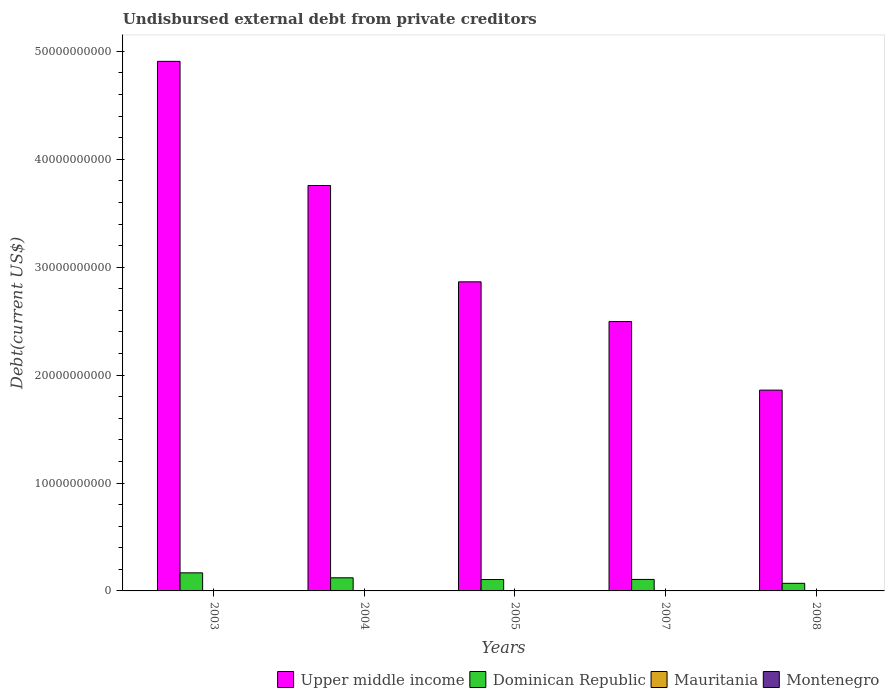Are the number of bars on each tick of the X-axis equal?
Provide a succinct answer. Yes. How many bars are there on the 4th tick from the right?
Ensure brevity in your answer.  4. What is the label of the 3rd group of bars from the left?
Your answer should be compact. 2005. What is the total debt in Mauritania in 2007?
Make the answer very short. 5.10e+04. Across all years, what is the maximum total debt in Mauritania?
Keep it short and to the point. 1.71e+07. Across all years, what is the minimum total debt in Dominican Republic?
Provide a short and direct response. 7.04e+08. In which year was the total debt in Upper middle income maximum?
Provide a short and direct response. 2003. In which year was the total debt in Upper middle income minimum?
Provide a short and direct response. 2008. What is the total total debt in Montenegro in the graph?
Offer a very short reply. 6.93e+07. What is the difference between the total debt in Dominican Republic in 2004 and that in 2008?
Provide a succinct answer. 5.11e+08. What is the difference between the total debt in Upper middle income in 2005 and the total debt in Mauritania in 2003?
Your answer should be very brief. 2.86e+1. What is the average total debt in Upper middle income per year?
Give a very brief answer. 3.18e+1. In the year 2005, what is the difference between the total debt in Upper middle income and total debt in Mauritania?
Your answer should be compact. 2.86e+1. What is the difference between the highest and the second highest total debt in Upper middle income?
Ensure brevity in your answer.  1.15e+1. What is the difference between the highest and the lowest total debt in Dominican Republic?
Offer a terse response. 9.72e+08. In how many years, is the total debt in Upper middle income greater than the average total debt in Upper middle income taken over all years?
Offer a very short reply. 2. Is the sum of the total debt in Dominican Republic in 2004 and 2007 greater than the maximum total debt in Montenegro across all years?
Provide a succinct answer. Yes. What does the 1st bar from the left in 2008 represents?
Keep it short and to the point. Upper middle income. What does the 4th bar from the right in 2003 represents?
Provide a short and direct response. Upper middle income. Is it the case that in every year, the sum of the total debt in Montenegro and total debt in Upper middle income is greater than the total debt in Dominican Republic?
Make the answer very short. Yes. How many bars are there?
Your answer should be compact. 20. What is the difference between two consecutive major ticks on the Y-axis?
Your response must be concise. 1.00e+1. Does the graph contain any zero values?
Make the answer very short. No. Does the graph contain grids?
Keep it short and to the point. No. How many legend labels are there?
Offer a terse response. 4. What is the title of the graph?
Your answer should be very brief. Undisbursed external debt from private creditors. What is the label or title of the Y-axis?
Make the answer very short. Debt(current US$). What is the Debt(current US$) of Upper middle income in 2003?
Your response must be concise. 4.91e+1. What is the Debt(current US$) in Dominican Republic in 2003?
Make the answer very short. 1.68e+09. What is the Debt(current US$) of Mauritania in 2003?
Ensure brevity in your answer.  1.71e+07. What is the Debt(current US$) of Montenegro in 2003?
Make the answer very short. 2.10e+06. What is the Debt(current US$) of Upper middle income in 2004?
Provide a short and direct response. 3.76e+1. What is the Debt(current US$) in Dominican Republic in 2004?
Offer a very short reply. 1.22e+09. What is the Debt(current US$) in Mauritania in 2004?
Offer a terse response. 1.51e+07. What is the Debt(current US$) of Montenegro in 2004?
Give a very brief answer. 2.10e+06. What is the Debt(current US$) in Upper middle income in 2005?
Make the answer very short. 2.86e+1. What is the Debt(current US$) of Dominican Republic in 2005?
Your response must be concise. 1.06e+09. What is the Debt(current US$) in Mauritania in 2005?
Make the answer very short. 5.10e+04. What is the Debt(current US$) of Montenegro in 2005?
Keep it short and to the point. 2.10e+06. What is the Debt(current US$) in Upper middle income in 2007?
Offer a terse response. 2.50e+1. What is the Debt(current US$) in Dominican Republic in 2007?
Keep it short and to the point. 1.07e+09. What is the Debt(current US$) in Mauritania in 2007?
Provide a short and direct response. 5.10e+04. What is the Debt(current US$) in Montenegro in 2007?
Provide a succinct answer. 3.24e+07. What is the Debt(current US$) in Upper middle income in 2008?
Ensure brevity in your answer.  1.86e+1. What is the Debt(current US$) in Dominican Republic in 2008?
Offer a terse response. 7.04e+08. What is the Debt(current US$) of Mauritania in 2008?
Offer a terse response. 3.00e+04. What is the Debt(current US$) in Montenegro in 2008?
Keep it short and to the point. 3.06e+07. Across all years, what is the maximum Debt(current US$) in Upper middle income?
Offer a terse response. 4.91e+1. Across all years, what is the maximum Debt(current US$) of Dominican Republic?
Provide a short and direct response. 1.68e+09. Across all years, what is the maximum Debt(current US$) of Mauritania?
Provide a short and direct response. 1.71e+07. Across all years, what is the maximum Debt(current US$) in Montenegro?
Your answer should be compact. 3.24e+07. Across all years, what is the minimum Debt(current US$) in Upper middle income?
Give a very brief answer. 1.86e+1. Across all years, what is the minimum Debt(current US$) in Dominican Republic?
Offer a terse response. 7.04e+08. Across all years, what is the minimum Debt(current US$) in Mauritania?
Provide a short and direct response. 3.00e+04. Across all years, what is the minimum Debt(current US$) of Montenegro?
Your answer should be compact. 2.10e+06. What is the total Debt(current US$) in Upper middle income in the graph?
Provide a succinct answer. 1.59e+11. What is the total Debt(current US$) in Dominican Republic in the graph?
Ensure brevity in your answer.  5.72e+09. What is the total Debt(current US$) in Mauritania in the graph?
Keep it short and to the point. 3.23e+07. What is the total Debt(current US$) of Montenegro in the graph?
Offer a terse response. 6.93e+07. What is the difference between the Debt(current US$) of Upper middle income in 2003 and that in 2004?
Your answer should be compact. 1.15e+1. What is the difference between the Debt(current US$) in Dominican Republic in 2003 and that in 2004?
Your answer should be compact. 4.60e+08. What is the difference between the Debt(current US$) in Mauritania in 2003 and that in 2004?
Provide a succinct answer. 2.07e+06. What is the difference between the Debt(current US$) of Montenegro in 2003 and that in 2004?
Make the answer very short. 0. What is the difference between the Debt(current US$) of Upper middle income in 2003 and that in 2005?
Your answer should be very brief. 2.04e+1. What is the difference between the Debt(current US$) of Dominican Republic in 2003 and that in 2005?
Your answer should be compact. 6.19e+08. What is the difference between the Debt(current US$) in Mauritania in 2003 and that in 2005?
Offer a terse response. 1.71e+07. What is the difference between the Debt(current US$) in Upper middle income in 2003 and that in 2007?
Your response must be concise. 2.41e+1. What is the difference between the Debt(current US$) of Dominican Republic in 2003 and that in 2007?
Offer a very short reply. 6.10e+08. What is the difference between the Debt(current US$) in Mauritania in 2003 and that in 2007?
Provide a short and direct response. 1.71e+07. What is the difference between the Debt(current US$) of Montenegro in 2003 and that in 2007?
Ensure brevity in your answer.  -3.03e+07. What is the difference between the Debt(current US$) in Upper middle income in 2003 and that in 2008?
Your response must be concise. 3.05e+1. What is the difference between the Debt(current US$) in Dominican Republic in 2003 and that in 2008?
Provide a succinct answer. 9.72e+08. What is the difference between the Debt(current US$) in Mauritania in 2003 and that in 2008?
Your answer should be very brief. 1.71e+07. What is the difference between the Debt(current US$) of Montenegro in 2003 and that in 2008?
Give a very brief answer. -2.85e+07. What is the difference between the Debt(current US$) of Upper middle income in 2004 and that in 2005?
Provide a succinct answer. 8.93e+09. What is the difference between the Debt(current US$) in Dominican Republic in 2004 and that in 2005?
Your answer should be compact. 1.59e+08. What is the difference between the Debt(current US$) in Mauritania in 2004 and that in 2005?
Provide a short and direct response. 1.50e+07. What is the difference between the Debt(current US$) of Montenegro in 2004 and that in 2005?
Your answer should be compact. 0. What is the difference between the Debt(current US$) in Upper middle income in 2004 and that in 2007?
Your answer should be compact. 1.26e+1. What is the difference between the Debt(current US$) in Dominican Republic in 2004 and that in 2007?
Your answer should be very brief. 1.50e+08. What is the difference between the Debt(current US$) in Mauritania in 2004 and that in 2007?
Make the answer very short. 1.50e+07. What is the difference between the Debt(current US$) of Montenegro in 2004 and that in 2007?
Provide a succinct answer. -3.03e+07. What is the difference between the Debt(current US$) in Upper middle income in 2004 and that in 2008?
Ensure brevity in your answer.  1.90e+1. What is the difference between the Debt(current US$) in Dominican Republic in 2004 and that in 2008?
Offer a terse response. 5.11e+08. What is the difference between the Debt(current US$) in Mauritania in 2004 and that in 2008?
Ensure brevity in your answer.  1.50e+07. What is the difference between the Debt(current US$) of Montenegro in 2004 and that in 2008?
Ensure brevity in your answer.  -2.85e+07. What is the difference between the Debt(current US$) of Upper middle income in 2005 and that in 2007?
Keep it short and to the point. 3.68e+09. What is the difference between the Debt(current US$) in Dominican Republic in 2005 and that in 2007?
Give a very brief answer. -8.96e+06. What is the difference between the Debt(current US$) of Montenegro in 2005 and that in 2007?
Your answer should be very brief. -3.03e+07. What is the difference between the Debt(current US$) in Upper middle income in 2005 and that in 2008?
Give a very brief answer. 1.00e+1. What is the difference between the Debt(current US$) in Dominican Republic in 2005 and that in 2008?
Your answer should be compact. 3.53e+08. What is the difference between the Debt(current US$) in Mauritania in 2005 and that in 2008?
Offer a very short reply. 2.10e+04. What is the difference between the Debt(current US$) of Montenegro in 2005 and that in 2008?
Give a very brief answer. -2.85e+07. What is the difference between the Debt(current US$) in Upper middle income in 2007 and that in 2008?
Your answer should be very brief. 6.36e+09. What is the difference between the Debt(current US$) of Dominican Republic in 2007 and that in 2008?
Your response must be concise. 3.62e+08. What is the difference between the Debt(current US$) of Mauritania in 2007 and that in 2008?
Offer a terse response. 2.10e+04. What is the difference between the Debt(current US$) of Montenegro in 2007 and that in 2008?
Your response must be concise. 1.77e+06. What is the difference between the Debt(current US$) in Upper middle income in 2003 and the Debt(current US$) in Dominican Republic in 2004?
Your answer should be compact. 4.79e+1. What is the difference between the Debt(current US$) of Upper middle income in 2003 and the Debt(current US$) of Mauritania in 2004?
Your answer should be compact. 4.91e+1. What is the difference between the Debt(current US$) of Upper middle income in 2003 and the Debt(current US$) of Montenegro in 2004?
Make the answer very short. 4.91e+1. What is the difference between the Debt(current US$) in Dominican Republic in 2003 and the Debt(current US$) in Mauritania in 2004?
Ensure brevity in your answer.  1.66e+09. What is the difference between the Debt(current US$) in Dominican Republic in 2003 and the Debt(current US$) in Montenegro in 2004?
Keep it short and to the point. 1.67e+09. What is the difference between the Debt(current US$) in Mauritania in 2003 and the Debt(current US$) in Montenegro in 2004?
Your answer should be compact. 1.50e+07. What is the difference between the Debt(current US$) of Upper middle income in 2003 and the Debt(current US$) of Dominican Republic in 2005?
Offer a terse response. 4.80e+1. What is the difference between the Debt(current US$) of Upper middle income in 2003 and the Debt(current US$) of Mauritania in 2005?
Your response must be concise. 4.91e+1. What is the difference between the Debt(current US$) in Upper middle income in 2003 and the Debt(current US$) in Montenegro in 2005?
Your answer should be compact. 4.91e+1. What is the difference between the Debt(current US$) of Dominican Republic in 2003 and the Debt(current US$) of Mauritania in 2005?
Ensure brevity in your answer.  1.68e+09. What is the difference between the Debt(current US$) in Dominican Republic in 2003 and the Debt(current US$) in Montenegro in 2005?
Ensure brevity in your answer.  1.67e+09. What is the difference between the Debt(current US$) in Mauritania in 2003 and the Debt(current US$) in Montenegro in 2005?
Keep it short and to the point. 1.50e+07. What is the difference between the Debt(current US$) in Upper middle income in 2003 and the Debt(current US$) in Dominican Republic in 2007?
Your response must be concise. 4.80e+1. What is the difference between the Debt(current US$) in Upper middle income in 2003 and the Debt(current US$) in Mauritania in 2007?
Offer a very short reply. 4.91e+1. What is the difference between the Debt(current US$) of Upper middle income in 2003 and the Debt(current US$) of Montenegro in 2007?
Provide a succinct answer. 4.90e+1. What is the difference between the Debt(current US$) in Dominican Republic in 2003 and the Debt(current US$) in Mauritania in 2007?
Ensure brevity in your answer.  1.68e+09. What is the difference between the Debt(current US$) of Dominican Republic in 2003 and the Debt(current US$) of Montenegro in 2007?
Keep it short and to the point. 1.64e+09. What is the difference between the Debt(current US$) in Mauritania in 2003 and the Debt(current US$) in Montenegro in 2007?
Your response must be concise. -1.53e+07. What is the difference between the Debt(current US$) of Upper middle income in 2003 and the Debt(current US$) of Dominican Republic in 2008?
Your answer should be compact. 4.84e+1. What is the difference between the Debt(current US$) in Upper middle income in 2003 and the Debt(current US$) in Mauritania in 2008?
Your answer should be compact. 4.91e+1. What is the difference between the Debt(current US$) in Upper middle income in 2003 and the Debt(current US$) in Montenegro in 2008?
Keep it short and to the point. 4.90e+1. What is the difference between the Debt(current US$) in Dominican Republic in 2003 and the Debt(current US$) in Mauritania in 2008?
Give a very brief answer. 1.68e+09. What is the difference between the Debt(current US$) of Dominican Republic in 2003 and the Debt(current US$) of Montenegro in 2008?
Provide a succinct answer. 1.65e+09. What is the difference between the Debt(current US$) of Mauritania in 2003 and the Debt(current US$) of Montenegro in 2008?
Keep it short and to the point. -1.35e+07. What is the difference between the Debt(current US$) in Upper middle income in 2004 and the Debt(current US$) in Dominican Republic in 2005?
Keep it short and to the point. 3.65e+1. What is the difference between the Debt(current US$) of Upper middle income in 2004 and the Debt(current US$) of Mauritania in 2005?
Make the answer very short. 3.76e+1. What is the difference between the Debt(current US$) of Upper middle income in 2004 and the Debt(current US$) of Montenegro in 2005?
Offer a very short reply. 3.76e+1. What is the difference between the Debt(current US$) of Dominican Republic in 2004 and the Debt(current US$) of Mauritania in 2005?
Provide a short and direct response. 1.22e+09. What is the difference between the Debt(current US$) of Dominican Republic in 2004 and the Debt(current US$) of Montenegro in 2005?
Provide a succinct answer. 1.21e+09. What is the difference between the Debt(current US$) in Mauritania in 2004 and the Debt(current US$) in Montenegro in 2005?
Keep it short and to the point. 1.30e+07. What is the difference between the Debt(current US$) in Upper middle income in 2004 and the Debt(current US$) in Dominican Republic in 2007?
Ensure brevity in your answer.  3.65e+1. What is the difference between the Debt(current US$) of Upper middle income in 2004 and the Debt(current US$) of Mauritania in 2007?
Your response must be concise. 3.76e+1. What is the difference between the Debt(current US$) of Upper middle income in 2004 and the Debt(current US$) of Montenegro in 2007?
Give a very brief answer. 3.75e+1. What is the difference between the Debt(current US$) of Dominican Republic in 2004 and the Debt(current US$) of Mauritania in 2007?
Your response must be concise. 1.22e+09. What is the difference between the Debt(current US$) in Dominican Republic in 2004 and the Debt(current US$) in Montenegro in 2007?
Offer a terse response. 1.18e+09. What is the difference between the Debt(current US$) of Mauritania in 2004 and the Debt(current US$) of Montenegro in 2007?
Your answer should be very brief. -1.73e+07. What is the difference between the Debt(current US$) of Upper middle income in 2004 and the Debt(current US$) of Dominican Republic in 2008?
Keep it short and to the point. 3.69e+1. What is the difference between the Debt(current US$) in Upper middle income in 2004 and the Debt(current US$) in Mauritania in 2008?
Offer a very short reply. 3.76e+1. What is the difference between the Debt(current US$) in Upper middle income in 2004 and the Debt(current US$) in Montenegro in 2008?
Give a very brief answer. 3.75e+1. What is the difference between the Debt(current US$) in Dominican Republic in 2004 and the Debt(current US$) in Mauritania in 2008?
Make the answer very short. 1.22e+09. What is the difference between the Debt(current US$) of Dominican Republic in 2004 and the Debt(current US$) of Montenegro in 2008?
Your answer should be compact. 1.18e+09. What is the difference between the Debt(current US$) of Mauritania in 2004 and the Debt(current US$) of Montenegro in 2008?
Your response must be concise. -1.56e+07. What is the difference between the Debt(current US$) in Upper middle income in 2005 and the Debt(current US$) in Dominican Republic in 2007?
Your response must be concise. 2.76e+1. What is the difference between the Debt(current US$) in Upper middle income in 2005 and the Debt(current US$) in Mauritania in 2007?
Your response must be concise. 2.86e+1. What is the difference between the Debt(current US$) of Upper middle income in 2005 and the Debt(current US$) of Montenegro in 2007?
Provide a short and direct response. 2.86e+1. What is the difference between the Debt(current US$) of Dominican Republic in 2005 and the Debt(current US$) of Mauritania in 2007?
Give a very brief answer. 1.06e+09. What is the difference between the Debt(current US$) in Dominican Republic in 2005 and the Debt(current US$) in Montenegro in 2007?
Give a very brief answer. 1.02e+09. What is the difference between the Debt(current US$) in Mauritania in 2005 and the Debt(current US$) in Montenegro in 2007?
Provide a succinct answer. -3.23e+07. What is the difference between the Debt(current US$) of Upper middle income in 2005 and the Debt(current US$) of Dominican Republic in 2008?
Ensure brevity in your answer.  2.79e+1. What is the difference between the Debt(current US$) of Upper middle income in 2005 and the Debt(current US$) of Mauritania in 2008?
Offer a very short reply. 2.86e+1. What is the difference between the Debt(current US$) of Upper middle income in 2005 and the Debt(current US$) of Montenegro in 2008?
Provide a succinct answer. 2.86e+1. What is the difference between the Debt(current US$) in Dominican Republic in 2005 and the Debt(current US$) in Mauritania in 2008?
Provide a short and direct response. 1.06e+09. What is the difference between the Debt(current US$) of Dominican Republic in 2005 and the Debt(current US$) of Montenegro in 2008?
Your answer should be very brief. 1.03e+09. What is the difference between the Debt(current US$) of Mauritania in 2005 and the Debt(current US$) of Montenegro in 2008?
Offer a terse response. -3.06e+07. What is the difference between the Debt(current US$) in Upper middle income in 2007 and the Debt(current US$) in Dominican Republic in 2008?
Your response must be concise. 2.43e+1. What is the difference between the Debt(current US$) of Upper middle income in 2007 and the Debt(current US$) of Mauritania in 2008?
Your answer should be very brief. 2.50e+1. What is the difference between the Debt(current US$) in Upper middle income in 2007 and the Debt(current US$) in Montenegro in 2008?
Give a very brief answer. 2.49e+1. What is the difference between the Debt(current US$) in Dominican Republic in 2007 and the Debt(current US$) in Mauritania in 2008?
Your response must be concise. 1.07e+09. What is the difference between the Debt(current US$) of Dominican Republic in 2007 and the Debt(current US$) of Montenegro in 2008?
Offer a terse response. 1.03e+09. What is the difference between the Debt(current US$) of Mauritania in 2007 and the Debt(current US$) of Montenegro in 2008?
Offer a very short reply. -3.06e+07. What is the average Debt(current US$) of Upper middle income per year?
Your answer should be compact. 3.18e+1. What is the average Debt(current US$) of Dominican Republic per year?
Provide a succinct answer. 1.14e+09. What is the average Debt(current US$) in Mauritania per year?
Offer a terse response. 6.46e+06. What is the average Debt(current US$) in Montenegro per year?
Keep it short and to the point. 1.39e+07. In the year 2003, what is the difference between the Debt(current US$) of Upper middle income and Debt(current US$) of Dominican Republic?
Your response must be concise. 4.74e+1. In the year 2003, what is the difference between the Debt(current US$) in Upper middle income and Debt(current US$) in Mauritania?
Provide a succinct answer. 4.91e+1. In the year 2003, what is the difference between the Debt(current US$) of Upper middle income and Debt(current US$) of Montenegro?
Provide a short and direct response. 4.91e+1. In the year 2003, what is the difference between the Debt(current US$) in Dominican Republic and Debt(current US$) in Mauritania?
Offer a terse response. 1.66e+09. In the year 2003, what is the difference between the Debt(current US$) in Dominican Republic and Debt(current US$) in Montenegro?
Your response must be concise. 1.67e+09. In the year 2003, what is the difference between the Debt(current US$) of Mauritania and Debt(current US$) of Montenegro?
Offer a terse response. 1.50e+07. In the year 2004, what is the difference between the Debt(current US$) of Upper middle income and Debt(current US$) of Dominican Republic?
Keep it short and to the point. 3.64e+1. In the year 2004, what is the difference between the Debt(current US$) of Upper middle income and Debt(current US$) of Mauritania?
Make the answer very short. 3.76e+1. In the year 2004, what is the difference between the Debt(current US$) in Upper middle income and Debt(current US$) in Montenegro?
Provide a succinct answer. 3.76e+1. In the year 2004, what is the difference between the Debt(current US$) of Dominican Republic and Debt(current US$) of Mauritania?
Give a very brief answer. 1.20e+09. In the year 2004, what is the difference between the Debt(current US$) in Dominican Republic and Debt(current US$) in Montenegro?
Provide a short and direct response. 1.21e+09. In the year 2004, what is the difference between the Debt(current US$) of Mauritania and Debt(current US$) of Montenegro?
Your response must be concise. 1.30e+07. In the year 2005, what is the difference between the Debt(current US$) in Upper middle income and Debt(current US$) in Dominican Republic?
Give a very brief answer. 2.76e+1. In the year 2005, what is the difference between the Debt(current US$) of Upper middle income and Debt(current US$) of Mauritania?
Offer a very short reply. 2.86e+1. In the year 2005, what is the difference between the Debt(current US$) in Upper middle income and Debt(current US$) in Montenegro?
Make the answer very short. 2.86e+1. In the year 2005, what is the difference between the Debt(current US$) in Dominican Republic and Debt(current US$) in Mauritania?
Offer a terse response. 1.06e+09. In the year 2005, what is the difference between the Debt(current US$) of Dominican Republic and Debt(current US$) of Montenegro?
Provide a succinct answer. 1.05e+09. In the year 2005, what is the difference between the Debt(current US$) in Mauritania and Debt(current US$) in Montenegro?
Your response must be concise. -2.05e+06. In the year 2007, what is the difference between the Debt(current US$) of Upper middle income and Debt(current US$) of Dominican Republic?
Give a very brief answer. 2.39e+1. In the year 2007, what is the difference between the Debt(current US$) of Upper middle income and Debt(current US$) of Mauritania?
Offer a terse response. 2.50e+1. In the year 2007, what is the difference between the Debt(current US$) of Upper middle income and Debt(current US$) of Montenegro?
Your response must be concise. 2.49e+1. In the year 2007, what is the difference between the Debt(current US$) in Dominican Republic and Debt(current US$) in Mauritania?
Your answer should be very brief. 1.07e+09. In the year 2007, what is the difference between the Debt(current US$) in Dominican Republic and Debt(current US$) in Montenegro?
Keep it short and to the point. 1.03e+09. In the year 2007, what is the difference between the Debt(current US$) in Mauritania and Debt(current US$) in Montenegro?
Provide a short and direct response. -3.23e+07. In the year 2008, what is the difference between the Debt(current US$) in Upper middle income and Debt(current US$) in Dominican Republic?
Your answer should be very brief. 1.79e+1. In the year 2008, what is the difference between the Debt(current US$) in Upper middle income and Debt(current US$) in Mauritania?
Offer a very short reply. 1.86e+1. In the year 2008, what is the difference between the Debt(current US$) in Upper middle income and Debt(current US$) in Montenegro?
Your response must be concise. 1.86e+1. In the year 2008, what is the difference between the Debt(current US$) in Dominican Republic and Debt(current US$) in Mauritania?
Offer a terse response. 7.04e+08. In the year 2008, what is the difference between the Debt(current US$) in Dominican Republic and Debt(current US$) in Montenegro?
Give a very brief answer. 6.73e+08. In the year 2008, what is the difference between the Debt(current US$) of Mauritania and Debt(current US$) of Montenegro?
Offer a very short reply. -3.06e+07. What is the ratio of the Debt(current US$) of Upper middle income in 2003 to that in 2004?
Your response must be concise. 1.31. What is the ratio of the Debt(current US$) of Dominican Republic in 2003 to that in 2004?
Offer a very short reply. 1.38. What is the ratio of the Debt(current US$) in Mauritania in 2003 to that in 2004?
Your response must be concise. 1.14. What is the ratio of the Debt(current US$) of Upper middle income in 2003 to that in 2005?
Provide a succinct answer. 1.71. What is the ratio of the Debt(current US$) of Dominican Republic in 2003 to that in 2005?
Your answer should be compact. 1.59. What is the ratio of the Debt(current US$) of Mauritania in 2003 to that in 2005?
Provide a short and direct response. 335.71. What is the ratio of the Debt(current US$) in Montenegro in 2003 to that in 2005?
Make the answer very short. 1. What is the ratio of the Debt(current US$) of Upper middle income in 2003 to that in 2007?
Give a very brief answer. 1.97. What is the ratio of the Debt(current US$) of Dominican Republic in 2003 to that in 2007?
Ensure brevity in your answer.  1.57. What is the ratio of the Debt(current US$) in Mauritania in 2003 to that in 2007?
Your response must be concise. 335.71. What is the ratio of the Debt(current US$) in Montenegro in 2003 to that in 2007?
Provide a short and direct response. 0.06. What is the ratio of the Debt(current US$) of Upper middle income in 2003 to that in 2008?
Make the answer very short. 2.64. What is the ratio of the Debt(current US$) of Dominican Republic in 2003 to that in 2008?
Offer a very short reply. 2.38. What is the ratio of the Debt(current US$) of Mauritania in 2003 to that in 2008?
Provide a short and direct response. 570.7. What is the ratio of the Debt(current US$) in Montenegro in 2003 to that in 2008?
Offer a very short reply. 0.07. What is the ratio of the Debt(current US$) in Upper middle income in 2004 to that in 2005?
Your answer should be very brief. 1.31. What is the ratio of the Debt(current US$) in Dominican Republic in 2004 to that in 2005?
Your response must be concise. 1.15. What is the ratio of the Debt(current US$) of Mauritania in 2004 to that in 2005?
Provide a succinct answer. 295.12. What is the ratio of the Debt(current US$) in Montenegro in 2004 to that in 2005?
Your answer should be compact. 1. What is the ratio of the Debt(current US$) of Upper middle income in 2004 to that in 2007?
Provide a short and direct response. 1.51. What is the ratio of the Debt(current US$) of Dominican Republic in 2004 to that in 2007?
Offer a terse response. 1.14. What is the ratio of the Debt(current US$) of Mauritania in 2004 to that in 2007?
Your response must be concise. 295.12. What is the ratio of the Debt(current US$) of Montenegro in 2004 to that in 2007?
Your answer should be very brief. 0.06. What is the ratio of the Debt(current US$) of Upper middle income in 2004 to that in 2008?
Give a very brief answer. 2.02. What is the ratio of the Debt(current US$) of Dominican Republic in 2004 to that in 2008?
Make the answer very short. 1.73. What is the ratio of the Debt(current US$) of Mauritania in 2004 to that in 2008?
Your answer should be very brief. 501.7. What is the ratio of the Debt(current US$) of Montenegro in 2004 to that in 2008?
Your response must be concise. 0.07. What is the ratio of the Debt(current US$) of Upper middle income in 2005 to that in 2007?
Offer a very short reply. 1.15. What is the ratio of the Debt(current US$) of Mauritania in 2005 to that in 2007?
Your response must be concise. 1. What is the ratio of the Debt(current US$) of Montenegro in 2005 to that in 2007?
Provide a short and direct response. 0.06. What is the ratio of the Debt(current US$) of Upper middle income in 2005 to that in 2008?
Offer a very short reply. 1.54. What is the ratio of the Debt(current US$) of Dominican Republic in 2005 to that in 2008?
Offer a terse response. 1.5. What is the ratio of the Debt(current US$) of Mauritania in 2005 to that in 2008?
Offer a terse response. 1.7. What is the ratio of the Debt(current US$) in Montenegro in 2005 to that in 2008?
Offer a terse response. 0.07. What is the ratio of the Debt(current US$) of Upper middle income in 2007 to that in 2008?
Keep it short and to the point. 1.34. What is the ratio of the Debt(current US$) of Dominican Republic in 2007 to that in 2008?
Make the answer very short. 1.51. What is the ratio of the Debt(current US$) of Mauritania in 2007 to that in 2008?
Provide a short and direct response. 1.7. What is the ratio of the Debt(current US$) in Montenegro in 2007 to that in 2008?
Your response must be concise. 1.06. What is the difference between the highest and the second highest Debt(current US$) of Upper middle income?
Your answer should be compact. 1.15e+1. What is the difference between the highest and the second highest Debt(current US$) of Dominican Republic?
Offer a very short reply. 4.60e+08. What is the difference between the highest and the second highest Debt(current US$) in Mauritania?
Keep it short and to the point. 2.07e+06. What is the difference between the highest and the second highest Debt(current US$) in Montenegro?
Provide a short and direct response. 1.77e+06. What is the difference between the highest and the lowest Debt(current US$) in Upper middle income?
Offer a very short reply. 3.05e+1. What is the difference between the highest and the lowest Debt(current US$) in Dominican Republic?
Provide a short and direct response. 9.72e+08. What is the difference between the highest and the lowest Debt(current US$) of Mauritania?
Ensure brevity in your answer.  1.71e+07. What is the difference between the highest and the lowest Debt(current US$) of Montenegro?
Provide a succinct answer. 3.03e+07. 